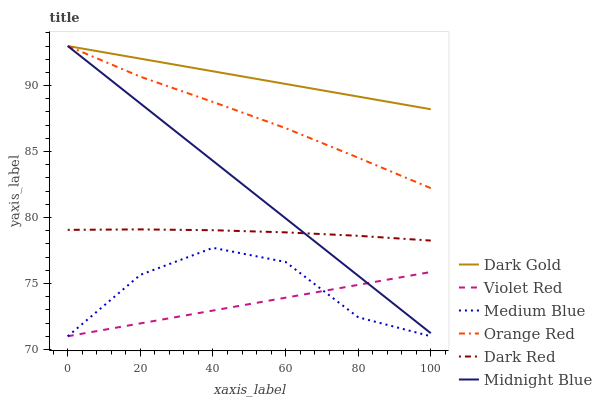Does Midnight Blue have the minimum area under the curve?
Answer yes or no. No. Does Midnight Blue have the maximum area under the curve?
Answer yes or no. No. Is Midnight Blue the smoothest?
Answer yes or no. No. Is Midnight Blue the roughest?
Answer yes or no. No. Does Midnight Blue have the lowest value?
Answer yes or no. No. Does Dark Red have the highest value?
Answer yes or no. No. Is Medium Blue less than Dark Red?
Answer yes or no. Yes. Is Dark Red greater than Violet Red?
Answer yes or no. Yes. Does Medium Blue intersect Dark Red?
Answer yes or no. No. 